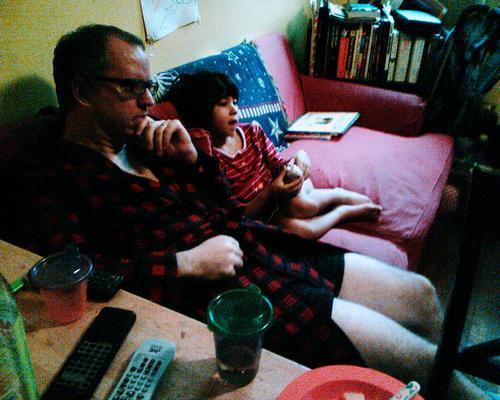How many children are there?
Give a very brief answer. 1. How many remotes are in the picture?
Give a very brief answer. 2. How many people are visible?
Give a very brief answer. 2. How many cups are there?
Give a very brief answer. 2. How many dogs are there?
Give a very brief answer. 0. 